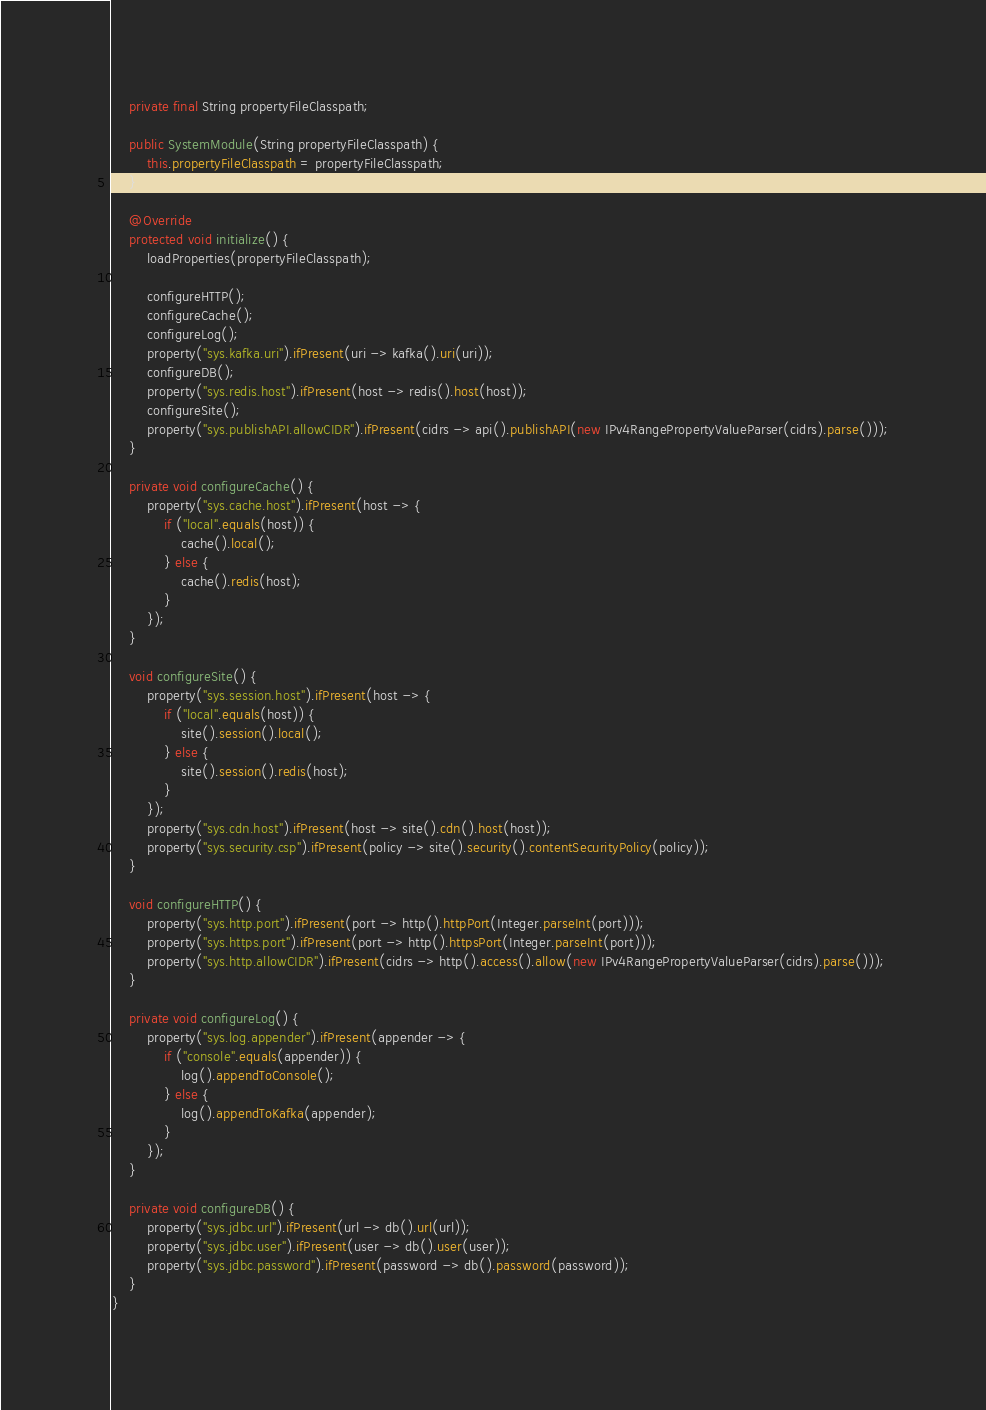<code> <loc_0><loc_0><loc_500><loc_500><_Java_>    private final String propertyFileClasspath;

    public SystemModule(String propertyFileClasspath) {
        this.propertyFileClasspath = propertyFileClasspath;
    }

    @Override
    protected void initialize() {
        loadProperties(propertyFileClasspath);

        configureHTTP();
        configureCache();
        configureLog();
        property("sys.kafka.uri").ifPresent(uri -> kafka().uri(uri));
        configureDB();
        property("sys.redis.host").ifPresent(host -> redis().host(host));
        configureSite();
        property("sys.publishAPI.allowCIDR").ifPresent(cidrs -> api().publishAPI(new IPv4RangePropertyValueParser(cidrs).parse()));
    }

    private void configureCache() {
        property("sys.cache.host").ifPresent(host -> {
            if ("local".equals(host)) {
                cache().local();
            } else {
                cache().redis(host);
            }
        });
    }

    void configureSite() {
        property("sys.session.host").ifPresent(host -> {
            if ("local".equals(host)) {
                site().session().local();
            } else {
                site().session().redis(host);
            }
        });
        property("sys.cdn.host").ifPresent(host -> site().cdn().host(host));
        property("sys.security.csp").ifPresent(policy -> site().security().contentSecurityPolicy(policy));
    }

    void configureHTTP() {
        property("sys.http.port").ifPresent(port -> http().httpPort(Integer.parseInt(port)));
        property("sys.https.port").ifPresent(port -> http().httpsPort(Integer.parseInt(port)));
        property("sys.http.allowCIDR").ifPresent(cidrs -> http().access().allow(new IPv4RangePropertyValueParser(cidrs).parse()));
    }

    private void configureLog() {
        property("sys.log.appender").ifPresent(appender -> {
            if ("console".equals(appender)) {
                log().appendToConsole();
            } else {
                log().appendToKafka(appender);
            }
        });
    }

    private void configureDB() {
        property("sys.jdbc.url").ifPresent(url -> db().url(url));
        property("sys.jdbc.user").ifPresent(user -> db().user(user));
        property("sys.jdbc.password").ifPresent(password -> db().password(password));
    }
}
</code> 